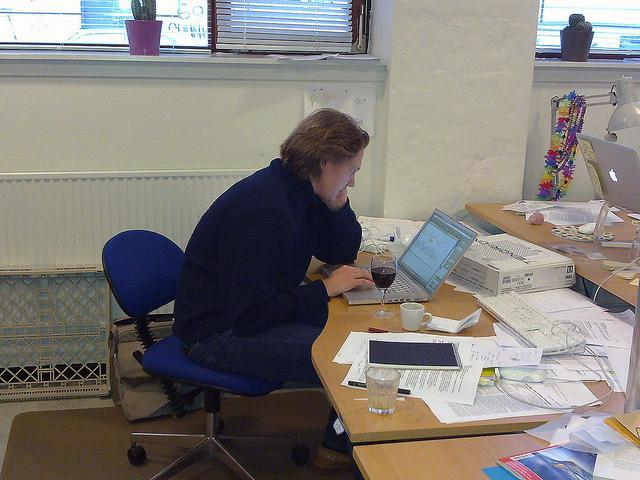Which liquid is most likely to be spilled on a laptop here?

Choices:
A) milk
B) water
C) milkshake
D) red wine red wine 